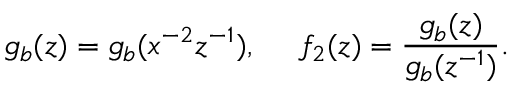<formula> <loc_0><loc_0><loc_500><loc_500>g _ { b } ( z ) = g _ { b } ( x ^ { - 2 } z ^ { - 1 } ) , f _ { 2 } ( z ) = \frac { g _ { b } ( z ) } { g _ { b } ( z ^ { - 1 } ) } .</formula> 